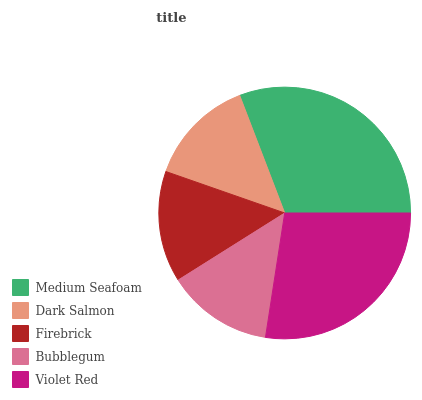Is Bubblegum the minimum?
Answer yes or no. Yes. Is Medium Seafoam the maximum?
Answer yes or no. Yes. Is Dark Salmon the minimum?
Answer yes or no. No. Is Dark Salmon the maximum?
Answer yes or no. No. Is Medium Seafoam greater than Dark Salmon?
Answer yes or no. Yes. Is Dark Salmon less than Medium Seafoam?
Answer yes or no. Yes. Is Dark Salmon greater than Medium Seafoam?
Answer yes or no. No. Is Medium Seafoam less than Dark Salmon?
Answer yes or no. No. Is Firebrick the high median?
Answer yes or no. Yes. Is Firebrick the low median?
Answer yes or no. Yes. Is Violet Red the high median?
Answer yes or no. No. Is Bubblegum the low median?
Answer yes or no. No. 